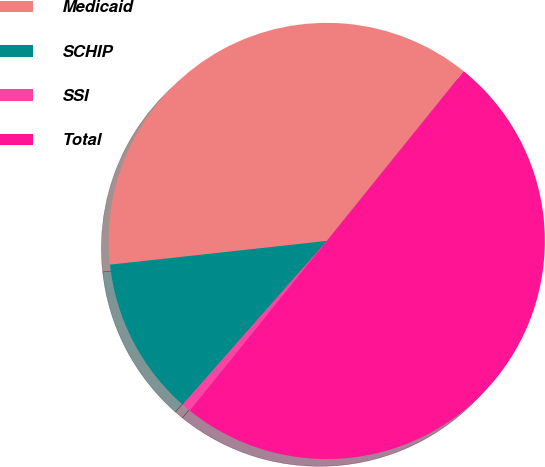<chart> <loc_0><loc_0><loc_500><loc_500><pie_chart><fcel>Medicaid<fcel>SCHIP<fcel>SSI<fcel>Total<nl><fcel>37.54%<fcel>11.78%<fcel>0.67%<fcel>50.0%<nl></chart> 